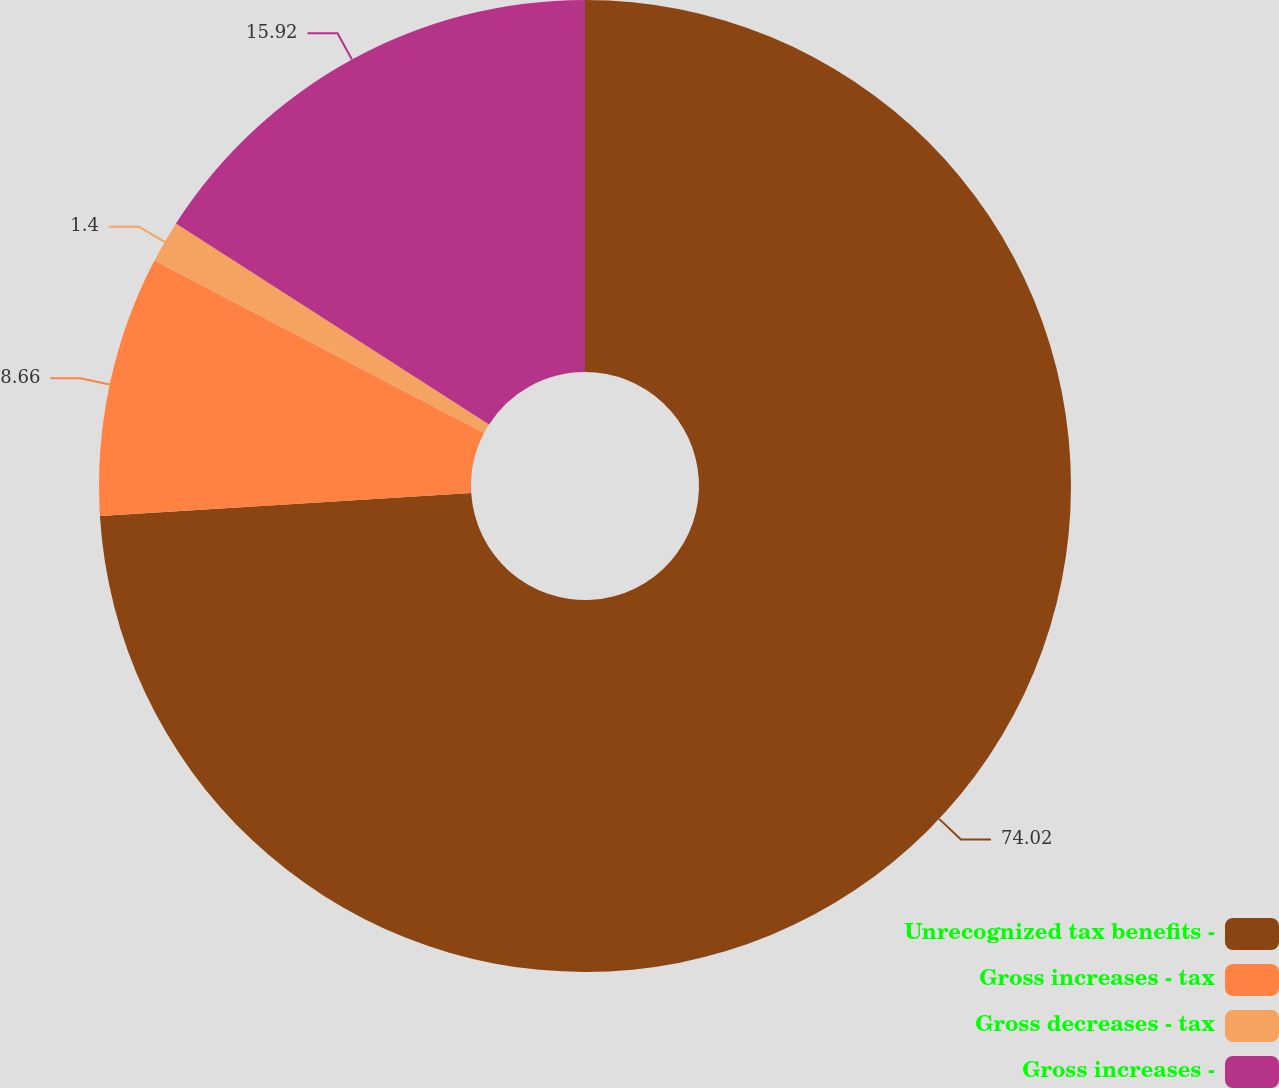<chart> <loc_0><loc_0><loc_500><loc_500><pie_chart><fcel>Unrecognized tax benefits -<fcel>Gross increases - tax<fcel>Gross decreases - tax<fcel>Gross increases -<nl><fcel>74.01%<fcel>8.66%<fcel>1.4%<fcel>15.92%<nl></chart> 